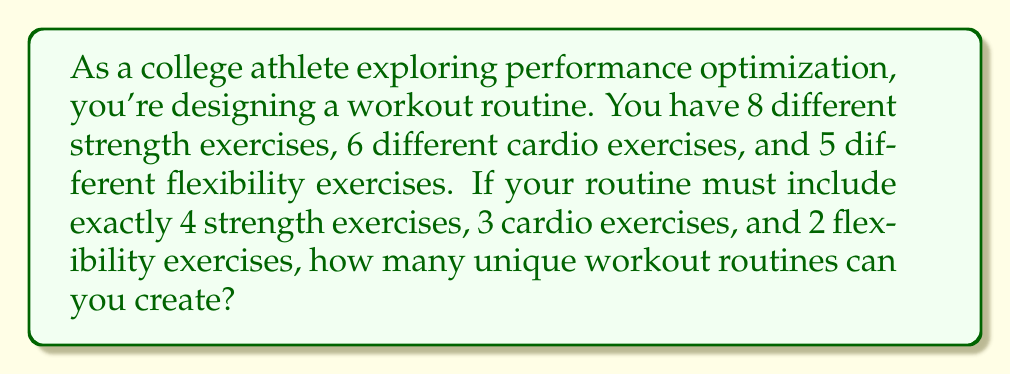Give your solution to this math problem. To solve this problem, we'll use the multiplication principle of counting and combinations. Let's break it down step-by-step:

1) For strength exercises:
   We need to choose 4 exercises out of 8 available. This is a combination problem.
   Number of ways to choose strength exercises = $\binom{8}{4}$

2) For cardio exercises:
   We need to choose 3 exercises out of 6 available.
   Number of ways to choose cardio exercises = $\binom{6}{3}$

3) For flexibility exercises:
   We need to choose 2 exercises out of 5 available.
   Number of ways to choose flexibility exercises = $\binom{5}{2}$

4) To calculate each combination:

   $\binom{8}{4} = \frac{8!}{4!(8-4)!} = \frac{8!}{4!4!} = 70$

   $\binom{6}{3} = \frac{6!}{3!(6-3)!} = \frac{6!}{3!3!} = 20$

   $\binom{5}{2} = \frac{5!}{2!(5-2)!} = \frac{5!}{2!3!} = 10$

5) By the multiplication principle, the total number of unique workout routines is the product of these combinations:

   Total routines = $70 \times 20 \times 10 = 14,000$

Therefore, you can create 14,000 unique workout routines with the given exercises and constraints.
Answer: 14,000 unique workout routines 